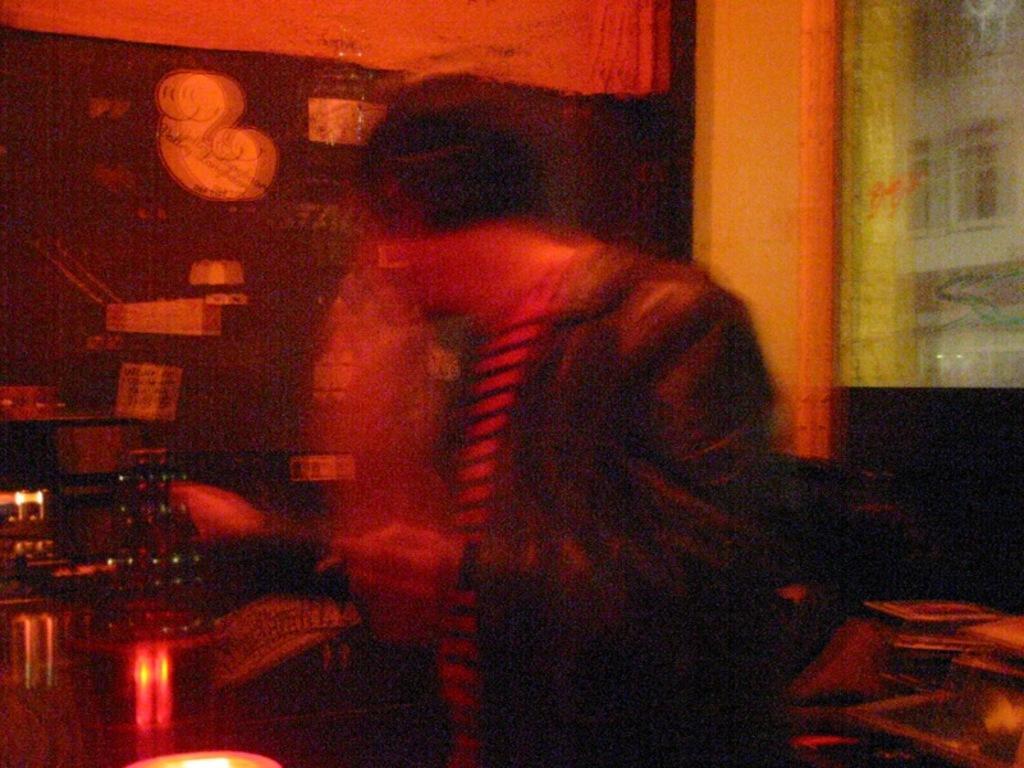Can you describe this image briefly? In this image we can see a person, around him there are some objects, on the left side of the image there is a wall with some objects and we can see a pillar. 